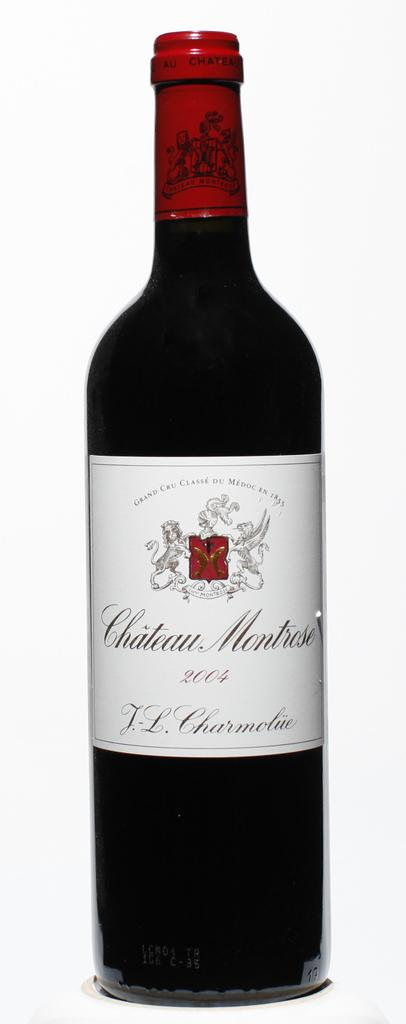<image>
Summarize the visual content of the image. A 2004 bottle of wine has a white label and red top. 